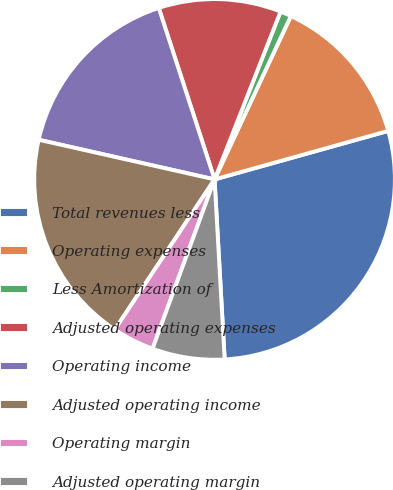<chart> <loc_0><loc_0><loc_500><loc_500><pie_chart><fcel>Total revenues less<fcel>Operating expenses<fcel>Less Amortization of<fcel>Adjusted operating expenses<fcel>Operating income<fcel>Adjusted operating income<fcel>Operating margin<fcel>Adjusted operating margin<nl><fcel>28.44%<fcel>13.71%<fcel>0.99%<fcel>10.97%<fcel>16.46%<fcel>19.2%<fcel>3.74%<fcel>6.48%<nl></chart> 